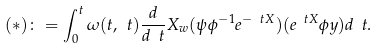<formula> <loc_0><loc_0><loc_500><loc_500>( * ) \colon = \int _ { 0 } ^ { t } \omega ( t , \ t ) \frac { d } { d \ t } X _ { w } ( \psi \phi ^ { - 1 } e ^ { - \ t X } ) ( e ^ { \ t X } \phi y ) d \ t .</formula> 